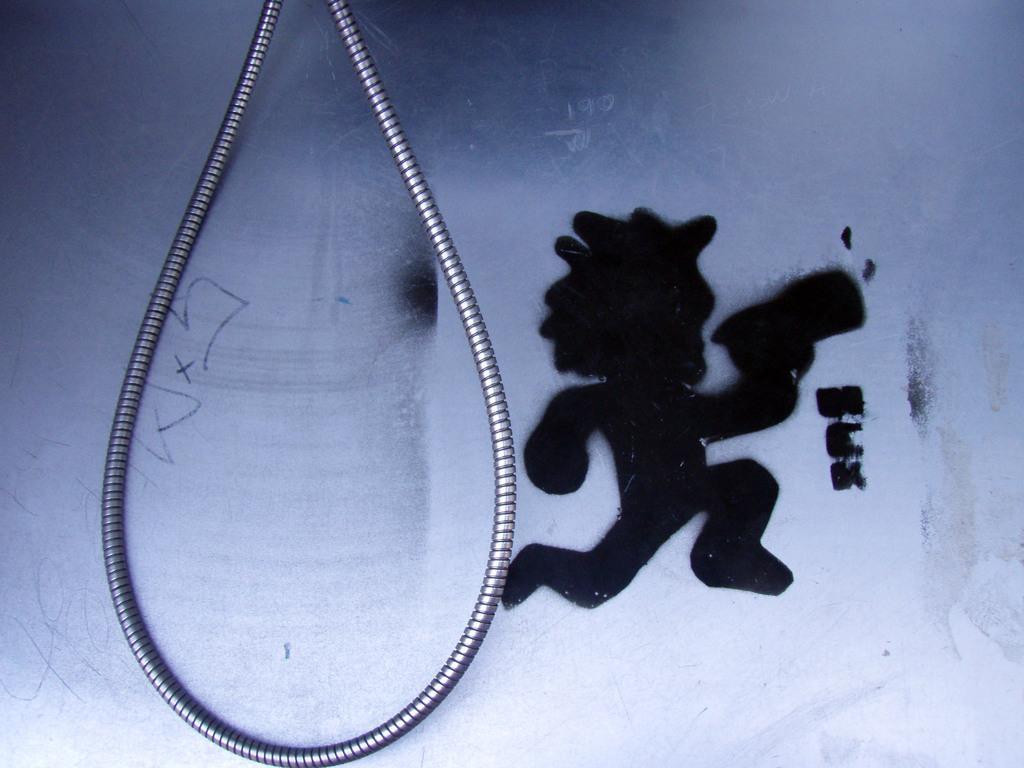How would you summarize this image in a sentence or two? On the right side of the image a graffiti is there. On the left side of the image a steel rope is present. 